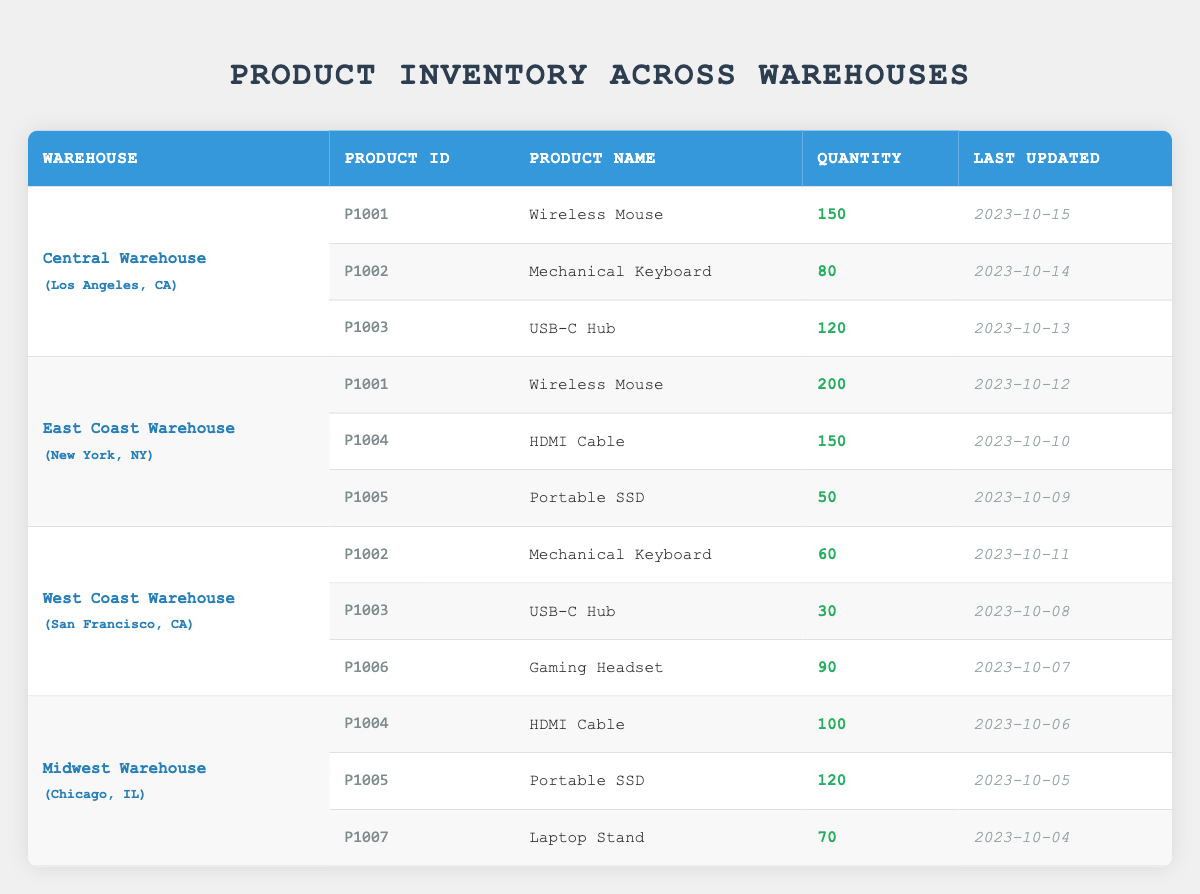What is the quantity of Wireless Mouses in the East Coast Warehouse? The East Coast Warehouse has one entry for the product "Wireless Mouse" with a quantity listed as 200.
Answer: 200 How many different types of products are stored in the West Coast Warehouse? The West Coast Warehouse has three entries: "Mechanical Keyboard," "USB-C Hub," and "Gaming Headset," which makes the total number of different products equal to three.
Answer: 3 Is there a Mechanical Keyboard available in the Central Warehouse? Yes, the Central Warehouse has a quantity of 80 for the product "Mechanical Keyboard," confirming its availability.
Answer: Yes What is the total quantity of HDMI Cables across all warehouses? The Central Warehouse does not have HDMI Cables, the East Coast Warehouse has 150, and the Midwest Warehouse has 100. Summing these two values gives 150 + 100 = 250.
Answer: 250 Which warehouse has the highest quantity of Portable SSDs, and what is that quantity? The East Coast Warehouse has 50, while the Midwest Warehouse has 120. Comparing these values shows that the Midwest Warehouse has a higher quantity of 120 for the product "Portable SSD."
Answer: Midwest Warehouse; 120 How many total products are in the Central Warehouse and the East Coast Warehouse combined? The Central Warehouse has 3 products and the East Coast Warehouse has 3 products. Thus, the total number becomes 3 + 3 = 6.
Answer: 6 What is the last updated date for the USB-C Hub in the West Coast Warehouse? The USB-C Hub in the West Coast Warehouse shows a last updated date of 2023-10-08.
Answer: 2023-10-08 Does the Midwest Warehouse contain any Gaming Headset? No, the Midwest Warehouse does not have a "Gaming Headset" listed in its inventory, as that product is only found in the West Coast Warehouse.
Answer: No What is the average quantity of Mechanical Keyboards across all the warehouses? Mechanical Keyboards are listed in the Central Warehouse with 80 and in the West Coast Warehouse with 60. The total is 80 + 60 = 140, and since there are 2 entries, the average is 140 / 2 = 70.
Answer: 70 